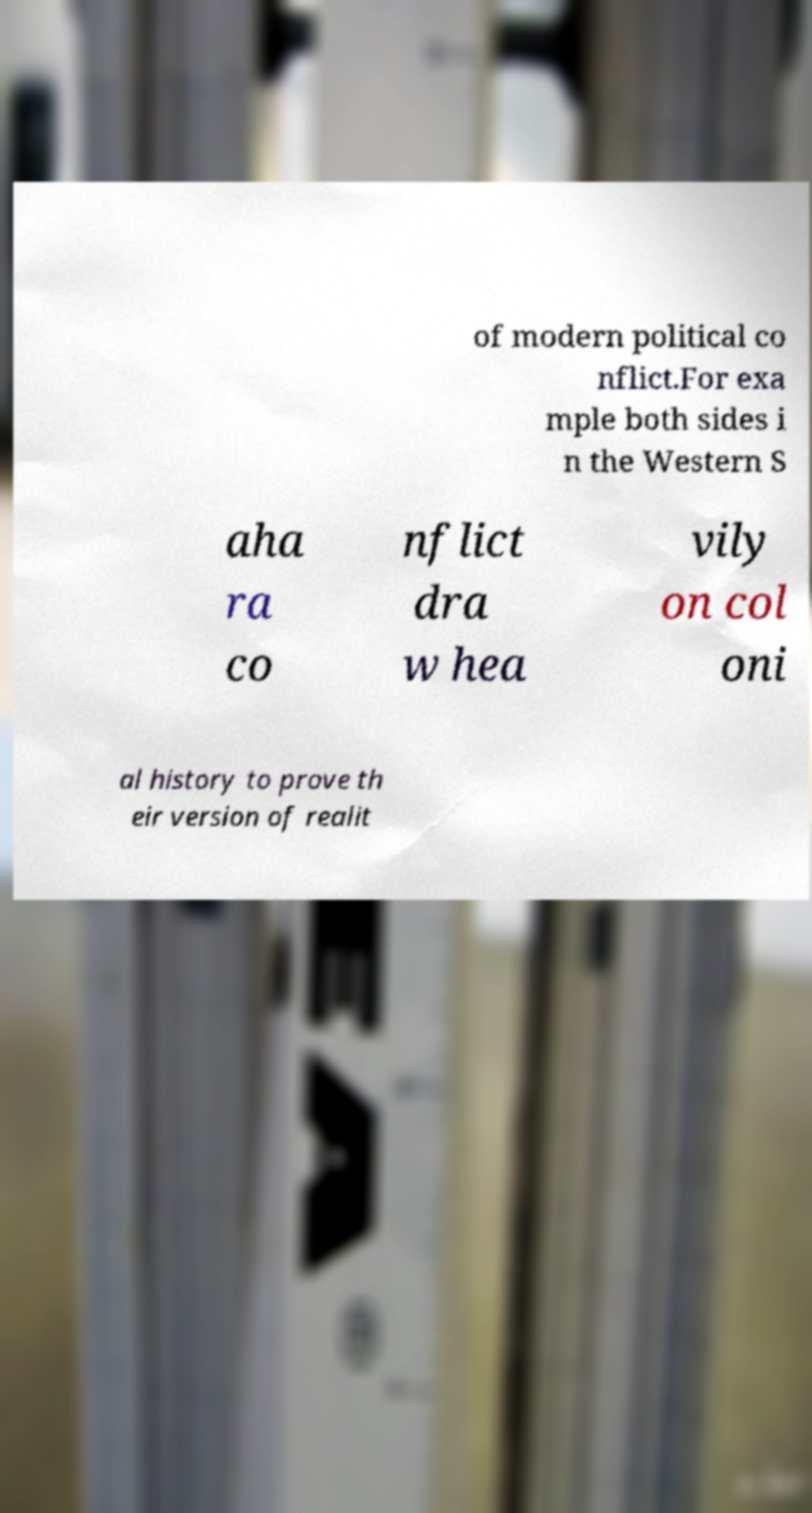Can you read and provide the text displayed in the image?This photo seems to have some interesting text. Can you extract and type it out for me? of modern political co nflict.For exa mple both sides i n the Western S aha ra co nflict dra w hea vily on col oni al history to prove th eir version of realit 